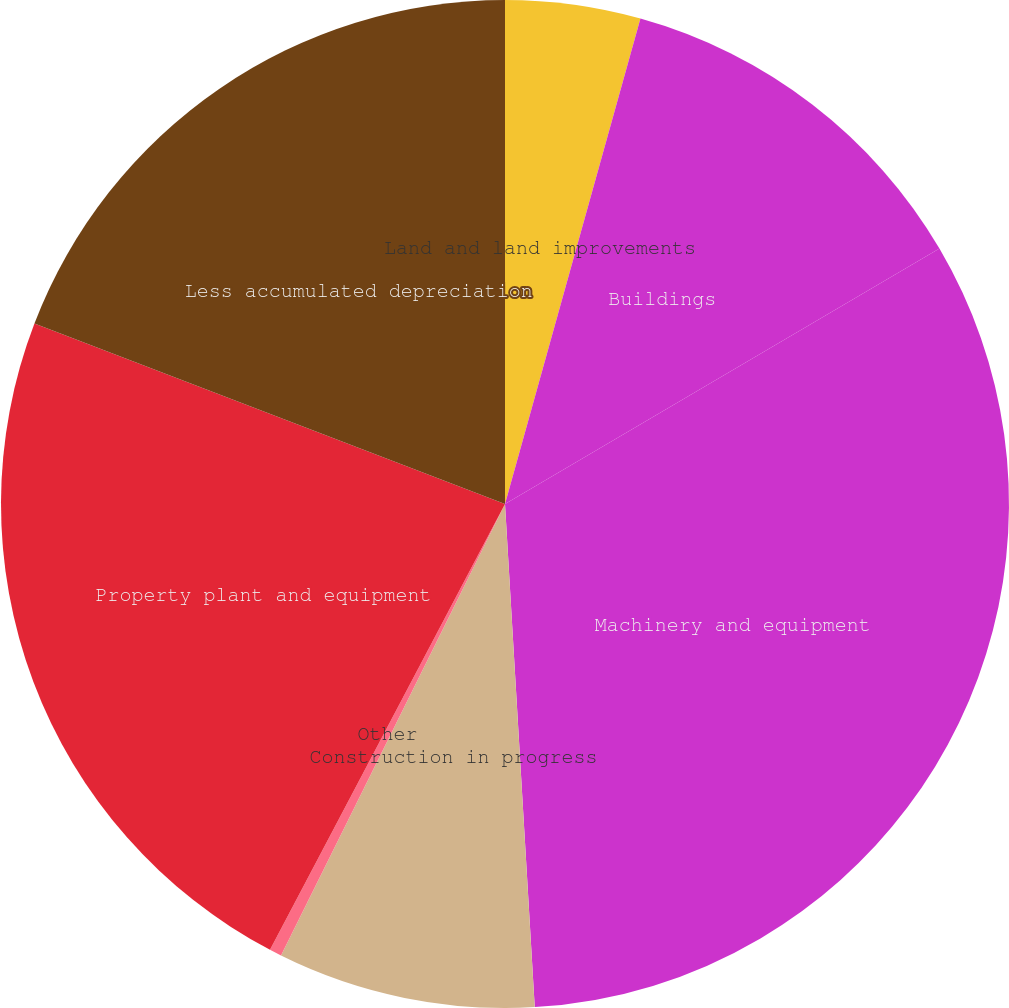<chart> <loc_0><loc_0><loc_500><loc_500><pie_chart><fcel>Land and land improvements<fcel>Buildings<fcel>Machinery and equipment<fcel>Construction in progress<fcel>Other<fcel>Property plant and equipment<fcel>Less accumulated depreciation<nl><fcel>4.33%<fcel>12.21%<fcel>32.52%<fcel>8.27%<fcel>0.39%<fcel>23.11%<fcel>19.17%<nl></chart> 